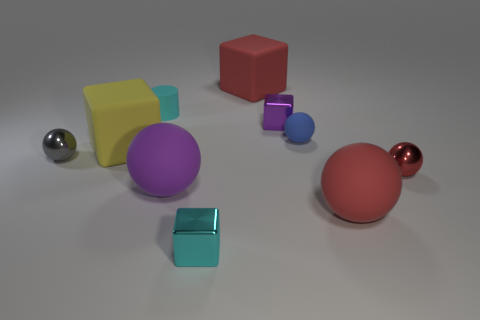Is there anything else that is the same shape as the big purple thing?
Your answer should be very brief. Yes. Do the purple thing behind the big purple object and the gray thing have the same material?
Provide a short and direct response. Yes. There is a thing that is in front of the large purple object and right of the small blue rubber thing; what is its shape?
Your response must be concise. Sphere. There is a tiny shiny sphere to the right of the gray shiny sphere; is there a cylinder on the right side of it?
Offer a terse response. No. What number of other objects are there of the same material as the small blue thing?
Make the answer very short. 5. Do the large red thing that is behind the cyan matte thing and the small cyan object in front of the small cyan cylinder have the same shape?
Provide a succinct answer. Yes. Are the tiny red object and the gray sphere made of the same material?
Provide a succinct answer. Yes. There is a purple thing that is to the right of the tiny metallic thing that is in front of the purple object that is to the left of the purple block; what is its size?
Provide a short and direct response. Small. What number of other objects are the same color as the small cylinder?
Offer a terse response. 1. There is a blue matte object that is the same size as the purple metallic block; what is its shape?
Offer a very short reply. Sphere. 